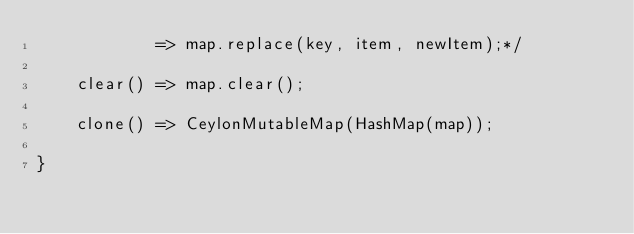Convert code to text. <code><loc_0><loc_0><loc_500><loc_500><_Ceylon_>            => map.replace(key, item, newItem);*/
    
    clear() => map.clear();
    
    clone() => CeylonMutableMap(HashMap(map));
    
}</code> 